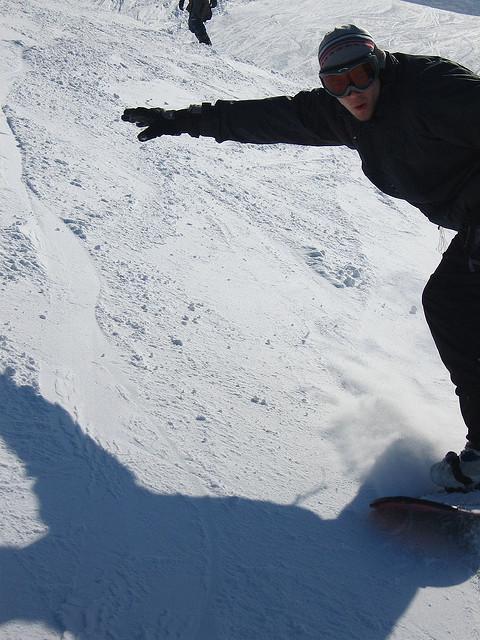How many of the trains are green on front?
Give a very brief answer. 0. 